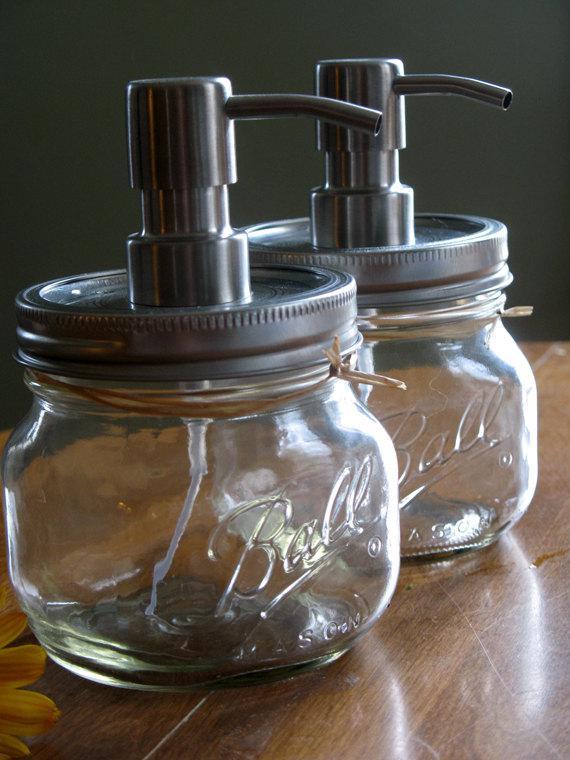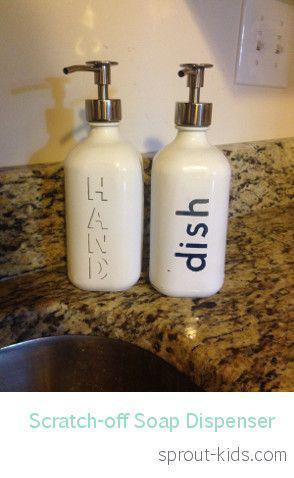The first image is the image on the left, the second image is the image on the right. Considering the images on both sides, is "One of the images shows at least one empty glass jar with a spout on top." valid? Answer yes or no. Yes. The first image is the image on the left, the second image is the image on the right. Examine the images to the left and right. Is the description "An image shows two opaque white dispensers side-by-side." accurate? Answer yes or no. Yes. 